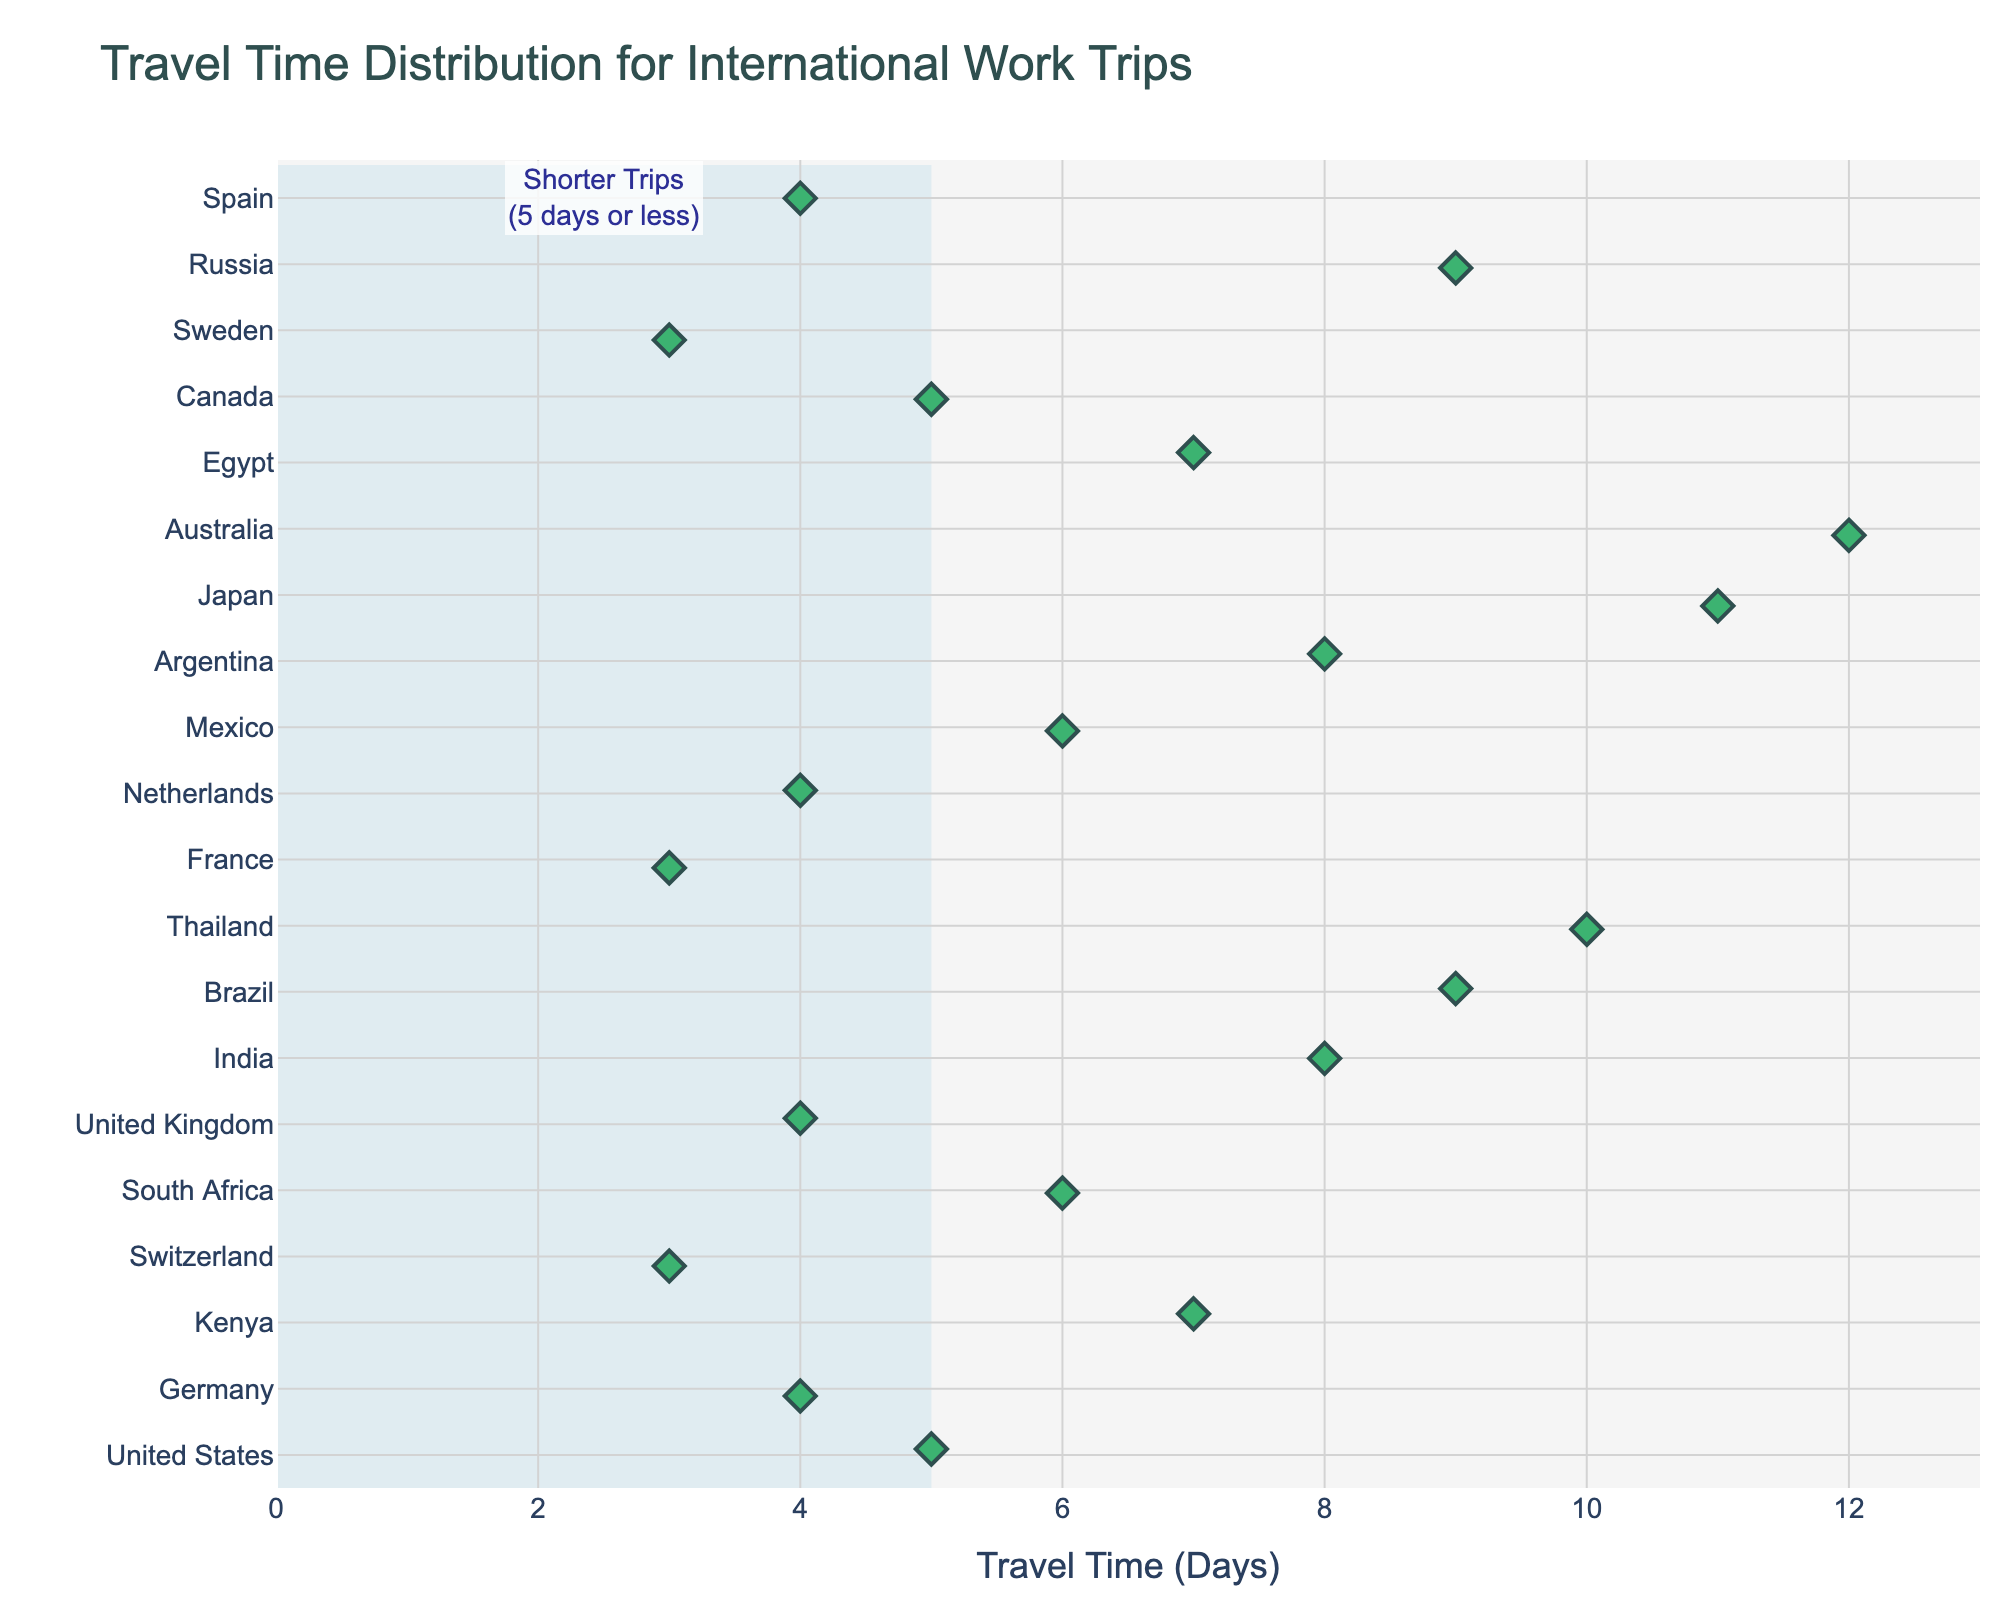What is the title of the figure? The title is located at the top of the plot and provides an immediate context for what the figure represents.
Answer: "Travel Time Distribution for International Work Trips" How many countries have a travel time of 4 days? Look for the data points aligned with the x-axis value of 4 days and count the corresponding countries on the y-axis.
Answer: 4 Which country has the longest travel time? Identify the data point farthest to the right on the x-axis and find the corresponding country on the y-axis.
Answer: Australia How many countries have travel times shorter than or equal to 5 days? Count the number of data points in the highlighted area marked as "Shorter Trips" which are less than or equal to 5 days.
Answer: 7 What is the range of travel times in the figure? The range is the difference between the maximum and minimum travel times shown on the x-axis. The minimum travel time is 3 days (Switzerland, France, Sweden) and the maximum is 12 days (Australia).
Answer: 9 days Which country has the shortest travel time, and what is it? Identify the data point farthest to the left on the x-axis and find the corresponding country on the y-axis.
Answer: Switzerland, France, and Sweden all have the shortest travel time of 3 days Is the travel time for trips to the United Kingdom shorter or longer than trips to Brazil? Compare the x-axis values for the United Kingdom and Brazil data points.
Answer: Shorter How many countries have travel times longer than 7 days? Count the number of data points that are greater than 7 days on the x-axis.
Answer: 6 What is the median travel time for the countries listed? Arrange all the travel time values in ascending order and find the middle value. Sorting: 3, 3, 3, 4, 4, 4, 4, 5, 5, 6, 6, 7, 7, 8, 8, 9, 9, 9, 10, 11, 12. The middle value in a dataset of 21 values is the 11th value.
Answer: 6 days How are shorter trips visually highlighted in the figure? Look at the visual markers and any annotations or shapes overlaying part of the plot. There is a light blue rectangle under the data points for shorter trips, accompanied by an annotation noting "Shorter Trips (5 days or less)."
Answer: Light blue rectangle and an annotation 